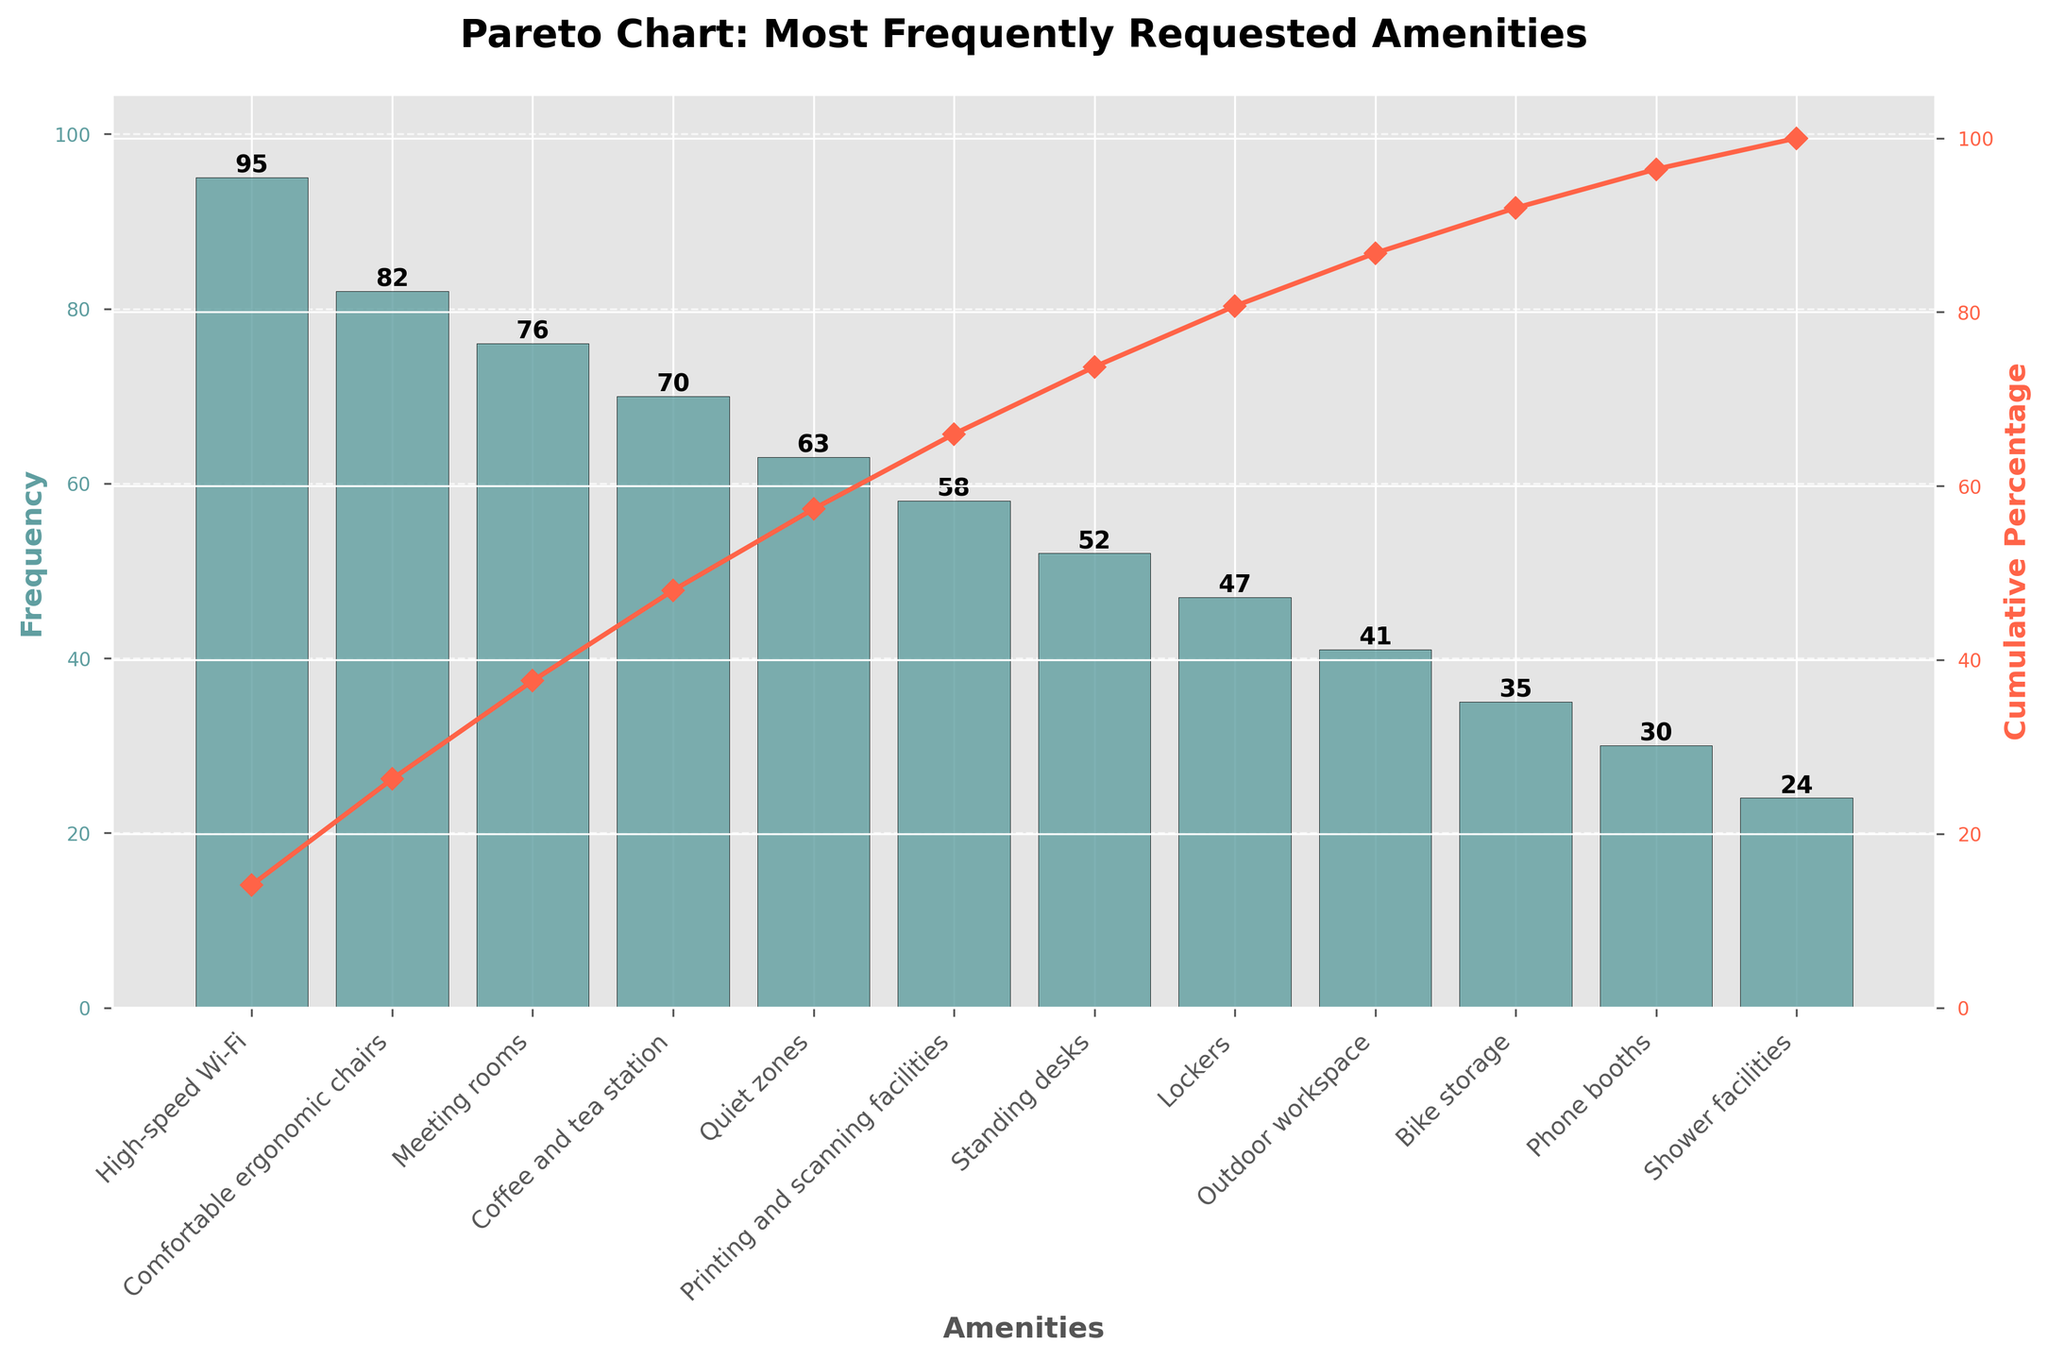what is the title of the figure? The title of the figure is usually found at the top and describes what the chart is about. In this case, it states the nature of the chart and the focus on frequently requested amenities.
Answer: Pareto Chart: Most Frequently Requested Amenities What amenity is the most frequently requested? To determine the most frequently requested amenity, look for the tallest bar in the chart. The label below this bar indicates the corresponding amenity.
Answer: High-speed Wi-Fi What is the frequency of requests for comfortable ergonomic chairs? Look at the bar labeled "Comfortable ergonomic chairs" and read the value on top of it to find the frequency.
Answer: 82 Which amenities have a cumulative percentage greater than 50%? Identify the cumulative percentage line (usually a curve) and see which amenities are to the right of where the curve crosses the 50% mark on the right y-axis.
Answer: High-speed Wi-Fi, Comfortable ergonomic chairs, Meeting rooms, Coffee and tea station What is the frequency difference between the most and the least requested amenities? Subtract the frequency of the least requested amenity from the frequency of the most requested one. The most requested is 'High-speed Wi-Fi' with 95, and the least is 'Shower facilities' with 24.
Answer: 71 What percentage of the requests are covered by the three most frequently requested amenities? Add the frequencies of the three most requested amenities (95 for High-speed Wi-Fi, 82 for Comfortable ergonomic chairs, and 76 for Meeting rooms), then calculate the percentage of the total (95 + 82 + 76)/673.
Answer: 37.88% How many amenities have frequencies greater than the median frequency? Identify the median value (the middle number when all frequencies are sorted). Sort the frequencies and find the middle value. In this case, with 11 amenities, the median is the 6th value. Count how many frequencies are greater than this median.
Answer: 5 What is the cumulative percentage after the fourth most requested amenity? Locate the fourth most requested amenity bar, then refer to the cumulative percentage line corresponding to the top of the fourth bar.
Answer: 54.69% Are there more amenities with a frequency greater than or less than 50? Count the number of amenities with a frequency greater than 50 and those with a frequency less than or equal to 50.
Answer: More amenities have a frequency greater than 50 At which point does the cumulative percentage exceed 90%? Follow the cumulative percentage line to see where it crosses the 90% mark on the right y-axis, and identify the corresponding amenity.
Answer: Outdoor workspace 